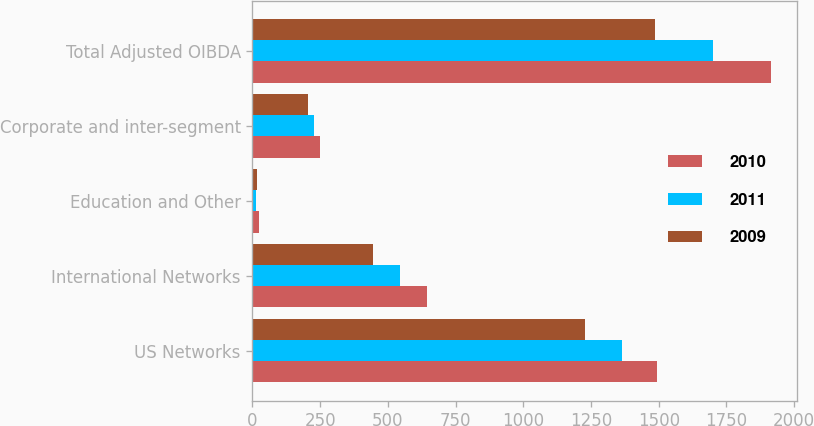Convert chart to OTSL. <chart><loc_0><loc_0><loc_500><loc_500><stacked_bar_chart><ecel><fcel>US Networks<fcel>International Networks<fcel>Education and Other<fcel>Corporate and inter-segment<fcel>Total Adjusted OIBDA<nl><fcel>2010<fcel>1495<fcel>645<fcel>23<fcel>249<fcel>1914<nl><fcel>2011<fcel>1365<fcel>545<fcel>15<fcel>226<fcel>1699<nl><fcel>2009<fcel>1229<fcel>445<fcel>16<fcel>204<fcel>1486<nl></chart> 